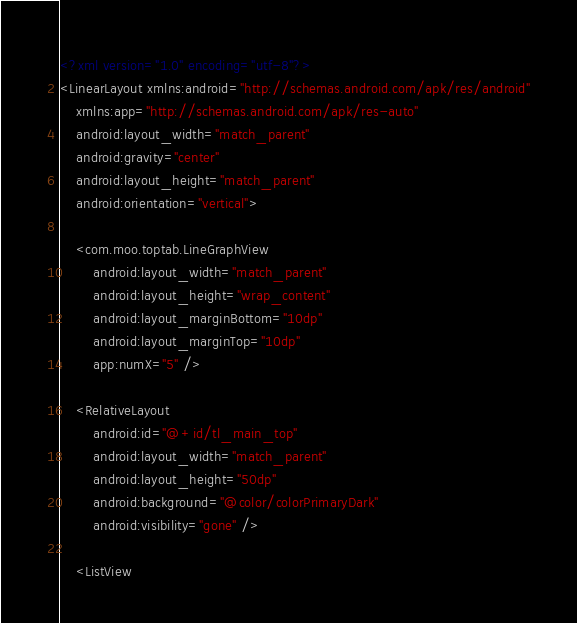<code> <loc_0><loc_0><loc_500><loc_500><_XML_><?xml version="1.0" encoding="utf-8"?>
<LinearLayout xmlns:android="http://schemas.android.com/apk/res/android"
    xmlns:app="http://schemas.android.com/apk/res-auto"
    android:layout_width="match_parent"
    android:gravity="center"
    android:layout_height="match_parent"
    android:orientation="vertical">

    <com.moo.toptab.LineGraphView
        android:layout_width="match_parent"
        android:layout_height="wrap_content"
        android:layout_marginBottom="10dp"
        android:layout_marginTop="10dp"
        app:numX="5" />

    <RelativeLayout
        android:id="@+id/tl_main_top"
        android:layout_width="match_parent"
        android:layout_height="50dp"
        android:background="@color/colorPrimaryDark"
        android:visibility="gone" />

    <ListView</code> 